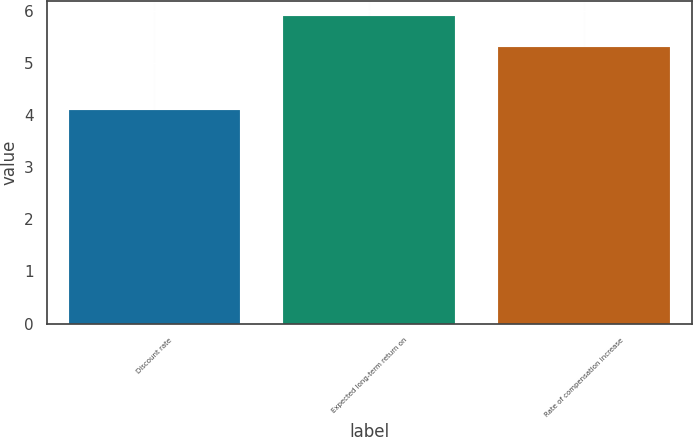Convert chart to OTSL. <chart><loc_0><loc_0><loc_500><loc_500><bar_chart><fcel>Discount rate<fcel>Expected long-term return on<fcel>Rate of compensation increase<nl><fcel>4.1<fcel>5.9<fcel>5.3<nl></chart> 